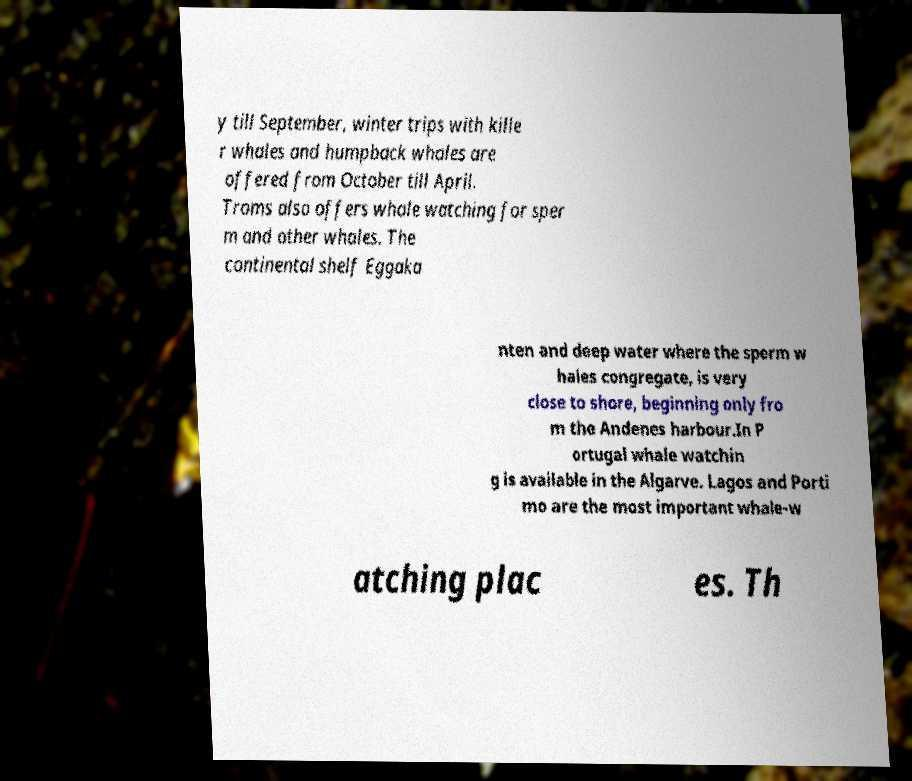What messages or text are displayed in this image? I need them in a readable, typed format. y till September, winter trips with kille r whales and humpback whales are offered from October till April. Troms also offers whale watching for sper m and other whales. The continental shelf Eggaka nten and deep water where the sperm w hales congregate, is very close to shore, beginning only fro m the Andenes harbour.In P ortugal whale watchin g is available in the Algarve. Lagos and Porti mo are the most important whale-w atching plac es. Th 